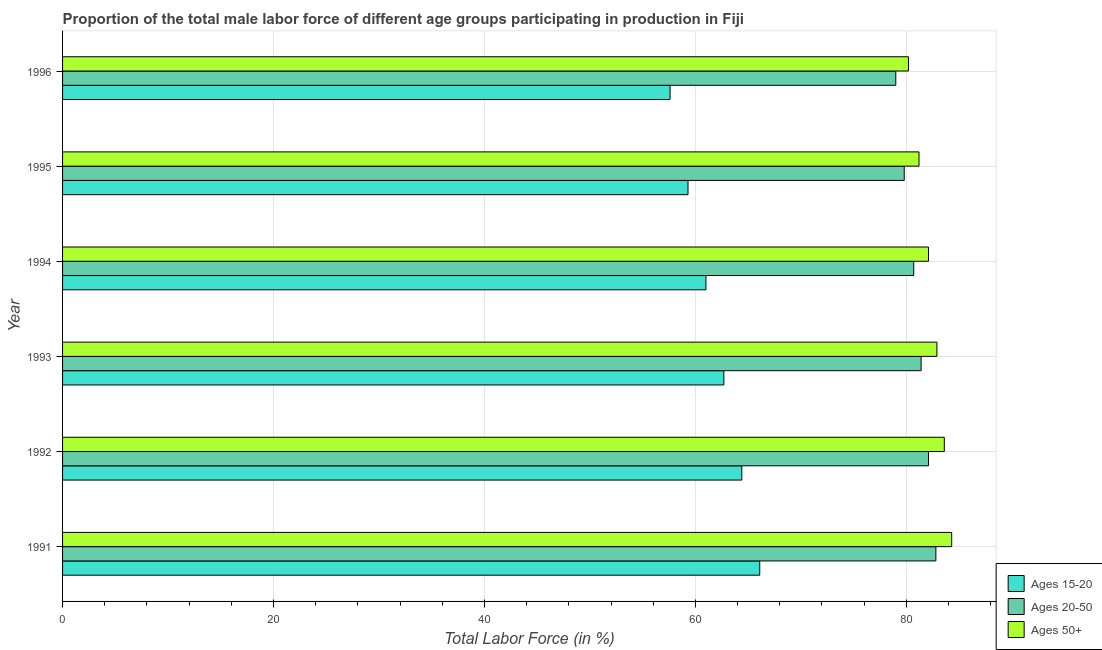Are the number of bars on each tick of the Y-axis equal?
Make the answer very short. Yes. How many bars are there on the 1st tick from the bottom?
Your response must be concise. 3. What is the percentage of male labor force above age 50 in 1993?
Offer a terse response. 82.9. Across all years, what is the maximum percentage of male labor force within the age group 15-20?
Ensure brevity in your answer.  66.1. Across all years, what is the minimum percentage of male labor force within the age group 20-50?
Provide a succinct answer. 79. In which year was the percentage of male labor force above age 50 minimum?
Give a very brief answer. 1996. What is the total percentage of male labor force within the age group 15-20 in the graph?
Your answer should be compact. 371.1. What is the difference between the percentage of male labor force above age 50 in 1993 and the percentage of male labor force within the age group 15-20 in 1995?
Provide a short and direct response. 23.6. What is the average percentage of male labor force within the age group 20-50 per year?
Provide a short and direct response. 80.97. In the year 1993, what is the difference between the percentage of male labor force above age 50 and percentage of male labor force within the age group 15-20?
Offer a very short reply. 20.2. In how many years, is the percentage of male labor force within the age group 15-20 greater than 80 %?
Offer a very short reply. 0. What is the ratio of the percentage of male labor force within the age group 20-50 in 1993 to that in 1995?
Ensure brevity in your answer.  1.02. What is the difference between the highest and the second highest percentage of male labor force within the age group 20-50?
Your answer should be very brief. 0.7. What is the difference between the highest and the lowest percentage of male labor force above age 50?
Offer a very short reply. 4.1. In how many years, is the percentage of male labor force within the age group 15-20 greater than the average percentage of male labor force within the age group 15-20 taken over all years?
Offer a terse response. 3. Is the sum of the percentage of male labor force within the age group 15-20 in 1992 and 1993 greater than the maximum percentage of male labor force within the age group 20-50 across all years?
Make the answer very short. Yes. What does the 2nd bar from the top in 1996 represents?
Your answer should be compact. Ages 20-50. What does the 3rd bar from the bottom in 1995 represents?
Your answer should be very brief. Ages 50+. Is it the case that in every year, the sum of the percentage of male labor force within the age group 15-20 and percentage of male labor force within the age group 20-50 is greater than the percentage of male labor force above age 50?
Make the answer very short. Yes. How many bars are there?
Keep it short and to the point. 18. Are all the bars in the graph horizontal?
Your answer should be compact. Yes. What is the difference between two consecutive major ticks on the X-axis?
Your answer should be compact. 20. Are the values on the major ticks of X-axis written in scientific E-notation?
Offer a very short reply. No. Does the graph contain grids?
Offer a very short reply. Yes. How many legend labels are there?
Make the answer very short. 3. How are the legend labels stacked?
Your answer should be very brief. Vertical. What is the title of the graph?
Keep it short and to the point. Proportion of the total male labor force of different age groups participating in production in Fiji. Does "Nuclear sources" appear as one of the legend labels in the graph?
Provide a short and direct response. No. What is the Total Labor Force (in %) of Ages 15-20 in 1991?
Give a very brief answer. 66.1. What is the Total Labor Force (in %) in Ages 20-50 in 1991?
Provide a succinct answer. 82.8. What is the Total Labor Force (in %) of Ages 50+ in 1991?
Offer a very short reply. 84.3. What is the Total Labor Force (in %) of Ages 15-20 in 1992?
Make the answer very short. 64.4. What is the Total Labor Force (in %) of Ages 20-50 in 1992?
Make the answer very short. 82.1. What is the Total Labor Force (in %) in Ages 50+ in 1992?
Make the answer very short. 83.6. What is the Total Labor Force (in %) in Ages 15-20 in 1993?
Your response must be concise. 62.7. What is the Total Labor Force (in %) of Ages 20-50 in 1993?
Keep it short and to the point. 81.4. What is the Total Labor Force (in %) of Ages 50+ in 1993?
Your response must be concise. 82.9. What is the Total Labor Force (in %) in Ages 15-20 in 1994?
Your answer should be very brief. 61. What is the Total Labor Force (in %) of Ages 20-50 in 1994?
Make the answer very short. 80.7. What is the Total Labor Force (in %) in Ages 50+ in 1994?
Your answer should be compact. 82.1. What is the Total Labor Force (in %) of Ages 15-20 in 1995?
Provide a short and direct response. 59.3. What is the Total Labor Force (in %) in Ages 20-50 in 1995?
Provide a succinct answer. 79.8. What is the Total Labor Force (in %) in Ages 50+ in 1995?
Your response must be concise. 81.2. What is the Total Labor Force (in %) of Ages 15-20 in 1996?
Ensure brevity in your answer.  57.6. What is the Total Labor Force (in %) in Ages 20-50 in 1996?
Your answer should be very brief. 79. What is the Total Labor Force (in %) of Ages 50+ in 1996?
Offer a terse response. 80.2. Across all years, what is the maximum Total Labor Force (in %) in Ages 15-20?
Give a very brief answer. 66.1. Across all years, what is the maximum Total Labor Force (in %) in Ages 20-50?
Provide a short and direct response. 82.8. Across all years, what is the maximum Total Labor Force (in %) in Ages 50+?
Ensure brevity in your answer.  84.3. Across all years, what is the minimum Total Labor Force (in %) of Ages 15-20?
Ensure brevity in your answer.  57.6. Across all years, what is the minimum Total Labor Force (in %) in Ages 20-50?
Ensure brevity in your answer.  79. Across all years, what is the minimum Total Labor Force (in %) of Ages 50+?
Keep it short and to the point. 80.2. What is the total Total Labor Force (in %) in Ages 15-20 in the graph?
Provide a succinct answer. 371.1. What is the total Total Labor Force (in %) of Ages 20-50 in the graph?
Make the answer very short. 485.8. What is the total Total Labor Force (in %) of Ages 50+ in the graph?
Provide a short and direct response. 494.3. What is the difference between the Total Labor Force (in %) in Ages 15-20 in 1991 and that in 1992?
Provide a short and direct response. 1.7. What is the difference between the Total Labor Force (in %) in Ages 20-50 in 1991 and that in 1992?
Keep it short and to the point. 0.7. What is the difference between the Total Labor Force (in %) of Ages 50+ in 1991 and that in 1992?
Your answer should be very brief. 0.7. What is the difference between the Total Labor Force (in %) of Ages 15-20 in 1991 and that in 1993?
Keep it short and to the point. 3.4. What is the difference between the Total Labor Force (in %) in Ages 20-50 in 1991 and that in 1993?
Give a very brief answer. 1.4. What is the difference between the Total Labor Force (in %) in Ages 50+ in 1991 and that in 1994?
Make the answer very short. 2.2. What is the difference between the Total Labor Force (in %) of Ages 20-50 in 1991 and that in 1995?
Provide a short and direct response. 3. What is the difference between the Total Labor Force (in %) in Ages 15-20 in 1991 and that in 1996?
Your answer should be very brief. 8.5. What is the difference between the Total Labor Force (in %) of Ages 20-50 in 1991 and that in 1996?
Make the answer very short. 3.8. What is the difference between the Total Labor Force (in %) of Ages 50+ in 1991 and that in 1996?
Your response must be concise. 4.1. What is the difference between the Total Labor Force (in %) in Ages 15-20 in 1992 and that in 1993?
Offer a terse response. 1.7. What is the difference between the Total Labor Force (in %) of Ages 50+ in 1992 and that in 1993?
Make the answer very short. 0.7. What is the difference between the Total Labor Force (in %) in Ages 15-20 in 1992 and that in 1994?
Offer a very short reply. 3.4. What is the difference between the Total Labor Force (in %) in Ages 20-50 in 1992 and that in 1994?
Your answer should be compact. 1.4. What is the difference between the Total Labor Force (in %) in Ages 50+ in 1992 and that in 1994?
Make the answer very short. 1.5. What is the difference between the Total Labor Force (in %) of Ages 15-20 in 1992 and that in 1995?
Make the answer very short. 5.1. What is the difference between the Total Labor Force (in %) in Ages 50+ in 1992 and that in 1995?
Offer a very short reply. 2.4. What is the difference between the Total Labor Force (in %) in Ages 50+ in 1992 and that in 1996?
Provide a short and direct response. 3.4. What is the difference between the Total Labor Force (in %) of Ages 20-50 in 1993 and that in 1994?
Offer a very short reply. 0.7. What is the difference between the Total Labor Force (in %) in Ages 50+ in 1993 and that in 1994?
Provide a short and direct response. 0.8. What is the difference between the Total Labor Force (in %) in Ages 15-20 in 1993 and that in 1995?
Provide a succinct answer. 3.4. What is the difference between the Total Labor Force (in %) in Ages 20-50 in 1993 and that in 1995?
Provide a succinct answer. 1.6. What is the difference between the Total Labor Force (in %) of Ages 50+ in 1993 and that in 1995?
Keep it short and to the point. 1.7. What is the difference between the Total Labor Force (in %) in Ages 15-20 in 1994 and that in 1995?
Make the answer very short. 1.7. What is the difference between the Total Labor Force (in %) in Ages 20-50 in 1994 and that in 1995?
Keep it short and to the point. 0.9. What is the difference between the Total Labor Force (in %) of Ages 50+ in 1994 and that in 1995?
Ensure brevity in your answer.  0.9. What is the difference between the Total Labor Force (in %) in Ages 50+ in 1994 and that in 1996?
Keep it short and to the point. 1.9. What is the difference between the Total Labor Force (in %) of Ages 15-20 in 1995 and that in 1996?
Provide a succinct answer. 1.7. What is the difference between the Total Labor Force (in %) in Ages 15-20 in 1991 and the Total Labor Force (in %) in Ages 20-50 in 1992?
Make the answer very short. -16. What is the difference between the Total Labor Force (in %) in Ages 15-20 in 1991 and the Total Labor Force (in %) in Ages 50+ in 1992?
Your response must be concise. -17.5. What is the difference between the Total Labor Force (in %) in Ages 20-50 in 1991 and the Total Labor Force (in %) in Ages 50+ in 1992?
Provide a succinct answer. -0.8. What is the difference between the Total Labor Force (in %) of Ages 15-20 in 1991 and the Total Labor Force (in %) of Ages 20-50 in 1993?
Give a very brief answer. -15.3. What is the difference between the Total Labor Force (in %) of Ages 15-20 in 1991 and the Total Labor Force (in %) of Ages 50+ in 1993?
Offer a very short reply. -16.8. What is the difference between the Total Labor Force (in %) in Ages 20-50 in 1991 and the Total Labor Force (in %) in Ages 50+ in 1993?
Give a very brief answer. -0.1. What is the difference between the Total Labor Force (in %) of Ages 15-20 in 1991 and the Total Labor Force (in %) of Ages 20-50 in 1994?
Offer a terse response. -14.6. What is the difference between the Total Labor Force (in %) in Ages 15-20 in 1991 and the Total Labor Force (in %) in Ages 50+ in 1994?
Your answer should be compact. -16. What is the difference between the Total Labor Force (in %) in Ages 20-50 in 1991 and the Total Labor Force (in %) in Ages 50+ in 1994?
Keep it short and to the point. 0.7. What is the difference between the Total Labor Force (in %) in Ages 15-20 in 1991 and the Total Labor Force (in %) in Ages 20-50 in 1995?
Your response must be concise. -13.7. What is the difference between the Total Labor Force (in %) of Ages 15-20 in 1991 and the Total Labor Force (in %) of Ages 50+ in 1995?
Your answer should be compact. -15.1. What is the difference between the Total Labor Force (in %) of Ages 15-20 in 1991 and the Total Labor Force (in %) of Ages 50+ in 1996?
Make the answer very short. -14.1. What is the difference between the Total Labor Force (in %) of Ages 20-50 in 1991 and the Total Labor Force (in %) of Ages 50+ in 1996?
Make the answer very short. 2.6. What is the difference between the Total Labor Force (in %) of Ages 15-20 in 1992 and the Total Labor Force (in %) of Ages 50+ in 1993?
Ensure brevity in your answer.  -18.5. What is the difference between the Total Labor Force (in %) in Ages 15-20 in 1992 and the Total Labor Force (in %) in Ages 20-50 in 1994?
Your answer should be compact. -16.3. What is the difference between the Total Labor Force (in %) in Ages 15-20 in 1992 and the Total Labor Force (in %) in Ages 50+ in 1994?
Your answer should be compact. -17.7. What is the difference between the Total Labor Force (in %) of Ages 15-20 in 1992 and the Total Labor Force (in %) of Ages 20-50 in 1995?
Make the answer very short. -15.4. What is the difference between the Total Labor Force (in %) in Ages 15-20 in 1992 and the Total Labor Force (in %) in Ages 50+ in 1995?
Your answer should be very brief. -16.8. What is the difference between the Total Labor Force (in %) of Ages 20-50 in 1992 and the Total Labor Force (in %) of Ages 50+ in 1995?
Offer a very short reply. 0.9. What is the difference between the Total Labor Force (in %) of Ages 15-20 in 1992 and the Total Labor Force (in %) of Ages 20-50 in 1996?
Your answer should be compact. -14.6. What is the difference between the Total Labor Force (in %) of Ages 15-20 in 1992 and the Total Labor Force (in %) of Ages 50+ in 1996?
Your answer should be very brief. -15.8. What is the difference between the Total Labor Force (in %) in Ages 15-20 in 1993 and the Total Labor Force (in %) in Ages 20-50 in 1994?
Your response must be concise. -18. What is the difference between the Total Labor Force (in %) of Ages 15-20 in 1993 and the Total Labor Force (in %) of Ages 50+ in 1994?
Offer a terse response. -19.4. What is the difference between the Total Labor Force (in %) of Ages 20-50 in 1993 and the Total Labor Force (in %) of Ages 50+ in 1994?
Ensure brevity in your answer.  -0.7. What is the difference between the Total Labor Force (in %) in Ages 15-20 in 1993 and the Total Labor Force (in %) in Ages 20-50 in 1995?
Provide a short and direct response. -17.1. What is the difference between the Total Labor Force (in %) in Ages 15-20 in 1993 and the Total Labor Force (in %) in Ages 50+ in 1995?
Offer a terse response. -18.5. What is the difference between the Total Labor Force (in %) in Ages 15-20 in 1993 and the Total Labor Force (in %) in Ages 20-50 in 1996?
Provide a short and direct response. -16.3. What is the difference between the Total Labor Force (in %) of Ages 15-20 in 1993 and the Total Labor Force (in %) of Ages 50+ in 1996?
Ensure brevity in your answer.  -17.5. What is the difference between the Total Labor Force (in %) of Ages 15-20 in 1994 and the Total Labor Force (in %) of Ages 20-50 in 1995?
Provide a short and direct response. -18.8. What is the difference between the Total Labor Force (in %) in Ages 15-20 in 1994 and the Total Labor Force (in %) in Ages 50+ in 1995?
Offer a terse response. -20.2. What is the difference between the Total Labor Force (in %) in Ages 15-20 in 1994 and the Total Labor Force (in %) in Ages 20-50 in 1996?
Offer a very short reply. -18. What is the difference between the Total Labor Force (in %) in Ages 15-20 in 1994 and the Total Labor Force (in %) in Ages 50+ in 1996?
Offer a very short reply. -19.2. What is the difference between the Total Labor Force (in %) in Ages 15-20 in 1995 and the Total Labor Force (in %) in Ages 20-50 in 1996?
Provide a short and direct response. -19.7. What is the difference between the Total Labor Force (in %) of Ages 15-20 in 1995 and the Total Labor Force (in %) of Ages 50+ in 1996?
Your answer should be compact. -20.9. What is the difference between the Total Labor Force (in %) in Ages 20-50 in 1995 and the Total Labor Force (in %) in Ages 50+ in 1996?
Give a very brief answer. -0.4. What is the average Total Labor Force (in %) of Ages 15-20 per year?
Your answer should be compact. 61.85. What is the average Total Labor Force (in %) of Ages 20-50 per year?
Make the answer very short. 80.97. What is the average Total Labor Force (in %) of Ages 50+ per year?
Provide a short and direct response. 82.38. In the year 1991, what is the difference between the Total Labor Force (in %) of Ages 15-20 and Total Labor Force (in %) of Ages 20-50?
Offer a very short reply. -16.7. In the year 1991, what is the difference between the Total Labor Force (in %) of Ages 15-20 and Total Labor Force (in %) of Ages 50+?
Give a very brief answer. -18.2. In the year 1991, what is the difference between the Total Labor Force (in %) in Ages 20-50 and Total Labor Force (in %) in Ages 50+?
Your answer should be compact. -1.5. In the year 1992, what is the difference between the Total Labor Force (in %) of Ages 15-20 and Total Labor Force (in %) of Ages 20-50?
Your answer should be very brief. -17.7. In the year 1992, what is the difference between the Total Labor Force (in %) of Ages 15-20 and Total Labor Force (in %) of Ages 50+?
Provide a short and direct response. -19.2. In the year 1993, what is the difference between the Total Labor Force (in %) of Ages 15-20 and Total Labor Force (in %) of Ages 20-50?
Provide a succinct answer. -18.7. In the year 1993, what is the difference between the Total Labor Force (in %) of Ages 15-20 and Total Labor Force (in %) of Ages 50+?
Offer a terse response. -20.2. In the year 1994, what is the difference between the Total Labor Force (in %) in Ages 15-20 and Total Labor Force (in %) in Ages 20-50?
Ensure brevity in your answer.  -19.7. In the year 1994, what is the difference between the Total Labor Force (in %) of Ages 15-20 and Total Labor Force (in %) of Ages 50+?
Provide a succinct answer. -21.1. In the year 1995, what is the difference between the Total Labor Force (in %) in Ages 15-20 and Total Labor Force (in %) in Ages 20-50?
Offer a very short reply. -20.5. In the year 1995, what is the difference between the Total Labor Force (in %) in Ages 15-20 and Total Labor Force (in %) in Ages 50+?
Offer a very short reply. -21.9. In the year 1995, what is the difference between the Total Labor Force (in %) of Ages 20-50 and Total Labor Force (in %) of Ages 50+?
Your answer should be very brief. -1.4. In the year 1996, what is the difference between the Total Labor Force (in %) in Ages 15-20 and Total Labor Force (in %) in Ages 20-50?
Your answer should be compact. -21.4. In the year 1996, what is the difference between the Total Labor Force (in %) of Ages 15-20 and Total Labor Force (in %) of Ages 50+?
Offer a very short reply. -22.6. In the year 1996, what is the difference between the Total Labor Force (in %) in Ages 20-50 and Total Labor Force (in %) in Ages 50+?
Your response must be concise. -1.2. What is the ratio of the Total Labor Force (in %) of Ages 15-20 in 1991 to that in 1992?
Your answer should be very brief. 1.03. What is the ratio of the Total Labor Force (in %) in Ages 20-50 in 1991 to that in 1992?
Your answer should be compact. 1.01. What is the ratio of the Total Labor Force (in %) in Ages 50+ in 1991 to that in 1992?
Offer a terse response. 1.01. What is the ratio of the Total Labor Force (in %) of Ages 15-20 in 1991 to that in 1993?
Offer a terse response. 1.05. What is the ratio of the Total Labor Force (in %) of Ages 20-50 in 1991 to that in 1993?
Your answer should be compact. 1.02. What is the ratio of the Total Labor Force (in %) of Ages 50+ in 1991 to that in 1993?
Keep it short and to the point. 1.02. What is the ratio of the Total Labor Force (in %) of Ages 15-20 in 1991 to that in 1994?
Offer a very short reply. 1.08. What is the ratio of the Total Labor Force (in %) in Ages 20-50 in 1991 to that in 1994?
Make the answer very short. 1.03. What is the ratio of the Total Labor Force (in %) in Ages 50+ in 1991 to that in 1994?
Provide a succinct answer. 1.03. What is the ratio of the Total Labor Force (in %) in Ages 15-20 in 1991 to that in 1995?
Keep it short and to the point. 1.11. What is the ratio of the Total Labor Force (in %) in Ages 20-50 in 1991 to that in 1995?
Give a very brief answer. 1.04. What is the ratio of the Total Labor Force (in %) in Ages 50+ in 1991 to that in 1995?
Offer a very short reply. 1.04. What is the ratio of the Total Labor Force (in %) in Ages 15-20 in 1991 to that in 1996?
Give a very brief answer. 1.15. What is the ratio of the Total Labor Force (in %) in Ages 20-50 in 1991 to that in 1996?
Make the answer very short. 1.05. What is the ratio of the Total Labor Force (in %) of Ages 50+ in 1991 to that in 1996?
Make the answer very short. 1.05. What is the ratio of the Total Labor Force (in %) in Ages 15-20 in 1992 to that in 1993?
Provide a short and direct response. 1.03. What is the ratio of the Total Labor Force (in %) in Ages 20-50 in 1992 to that in 1993?
Ensure brevity in your answer.  1.01. What is the ratio of the Total Labor Force (in %) in Ages 50+ in 1992 to that in 1993?
Your response must be concise. 1.01. What is the ratio of the Total Labor Force (in %) in Ages 15-20 in 1992 to that in 1994?
Offer a very short reply. 1.06. What is the ratio of the Total Labor Force (in %) in Ages 20-50 in 1992 to that in 1994?
Your answer should be compact. 1.02. What is the ratio of the Total Labor Force (in %) of Ages 50+ in 1992 to that in 1994?
Your answer should be very brief. 1.02. What is the ratio of the Total Labor Force (in %) in Ages 15-20 in 1992 to that in 1995?
Your answer should be compact. 1.09. What is the ratio of the Total Labor Force (in %) of Ages 20-50 in 1992 to that in 1995?
Keep it short and to the point. 1.03. What is the ratio of the Total Labor Force (in %) of Ages 50+ in 1992 to that in 1995?
Provide a short and direct response. 1.03. What is the ratio of the Total Labor Force (in %) in Ages 15-20 in 1992 to that in 1996?
Provide a succinct answer. 1.12. What is the ratio of the Total Labor Force (in %) of Ages 20-50 in 1992 to that in 1996?
Keep it short and to the point. 1.04. What is the ratio of the Total Labor Force (in %) in Ages 50+ in 1992 to that in 1996?
Provide a short and direct response. 1.04. What is the ratio of the Total Labor Force (in %) in Ages 15-20 in 1993 to that in 1994?
Provide a succinct answer. 1.03. What is the ratio of the Total Labor Force (in %) in Ages 20-50 in 1993 to that in 1994?
Provide a succinct answer. 1.01. What is the ratio of the Total Labor Force (in %) of Ages 50+ in 1993 to that in 1994?
Ensure brevity in your answer.  1.01. What is the ratio of the Total Labor Force (in %) in Ages 15-20 in 1993 to that in 1995?
Ensure brevity in your answer.  1.06. What is the ratio of the Total Labor Force (in %) in Ages 20-50 in 1993 to that in 1995?
Give a very brief answer. 1.02. What is the ratio of the Total Labor Force (in %) of Ages 50+ in 1993 to that in 1995?
Your response must be concise. 1.02. What is the ratio of the Total Labor Force (in %) of Ages 15-20 in 1993 to that in 1996?
Give a very brief answer. 1.09. What is the ratio of the Total Labor Force (in %) of Ages 20-50 in 1993 to that in 1996?
Keep it short and to the point. 1.03. What is the ratio of the Total Labor Force (in %) of Ages 50+ in 1993 to that in 1996?
Provide a short and direct response. 1.03. What is the ratio of the Total Labor Force (in %) in Ages 15-20 in 1994 to that in 1995?
Ensure brevity in your answer.  1.03. What is the ratio of the Total Labor Force (in %) of Ages 20-50 in 1994 to that in 1995?
Keep it short and to the point. 1.01. What is the ratio of the Total Labor Force (in %) in Ages 50+ in 1994 to that in 1995?
Provide a succinct answer. 1.01. What is the ratio of the Total Labor Force (in %) of Ages 15-20 in 1994 to that in 1996?
Provide a succinct answer. 1.06. What is the ratio of the Total Labor Force (in %) of Ages 20-50 in 1994 to that in 1996?
Offer a very short reply. 1.02. What is the ratio of the Total Labor Force (in %) of Ages 50+ in 1994 to that in 1996?
Ensure brevity in your answer.  1.02. What is the ratio of the Total Labor Force (in %) in Ages 15-20 in 1995 to that in 1996?
Give a very brief answer. 1.03. What is the ratio of the Total Labor Force (in %) in Ages 50+ in 1995 to that in 1996?
Your answer should be compact. 1.01. What is the difference between the highest and the second highest Total Labor Force (in %) of Ages 20-50?
Offer a terse response. 0.7. What is the difference between the highest and the second highest Total Labor Force (in %) of Ages 50+?
Your response must be concise. 0.7. What is the difference between the highest and the lowest Total Labor Force (in %) in Ages 15-20?
Make the answer very short. 8.5. What is the difference between the highest and the lowest Total Labor Force (in %) in Ages 50+?
Offer a very short reply. 4.1. 